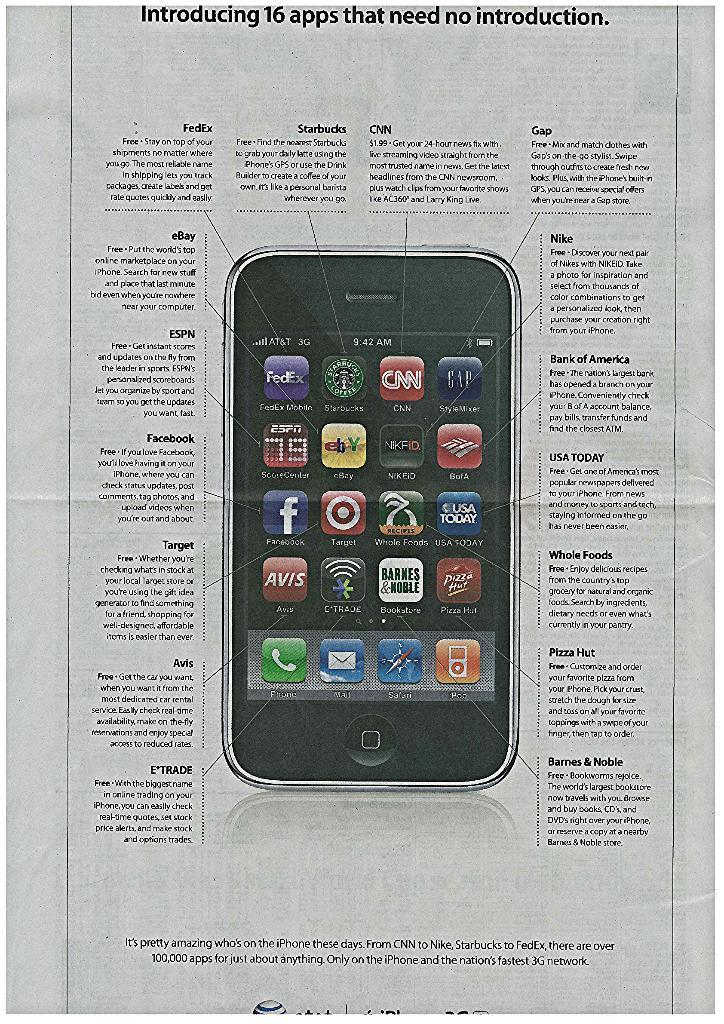<image>
Offer a succinct explanation of the picture presented. iphone print ad that introduces 16 apps that need no introduction 